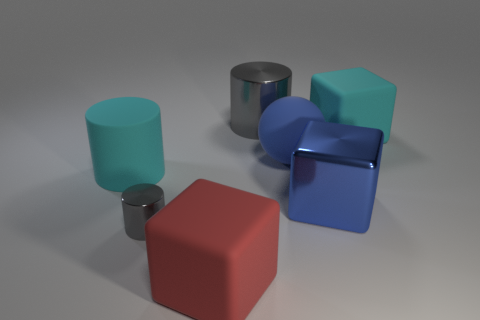Subtract all large cylinders. How many cylinders are left? 1 Subtract all green cubes. How many gray cylinders are left? 2 Add 1 blue rubber balls. How many objects exist? 8 Subtract all red cubes. How many cubes are left? 2 Subtract all balls. How many objects are left? 6 Subtract 1 spheres. How many spheres are left? 0 Add 7 blue cubes. How many blue cubes are left? 8 Add 2 rubber spheres. How many rubber spheres exist? 3 Subtract 1 blue balls. How many objects are left? 6 Subtract all cyan spheres. Subtract all red cylinders. How many spheres are left? 1 